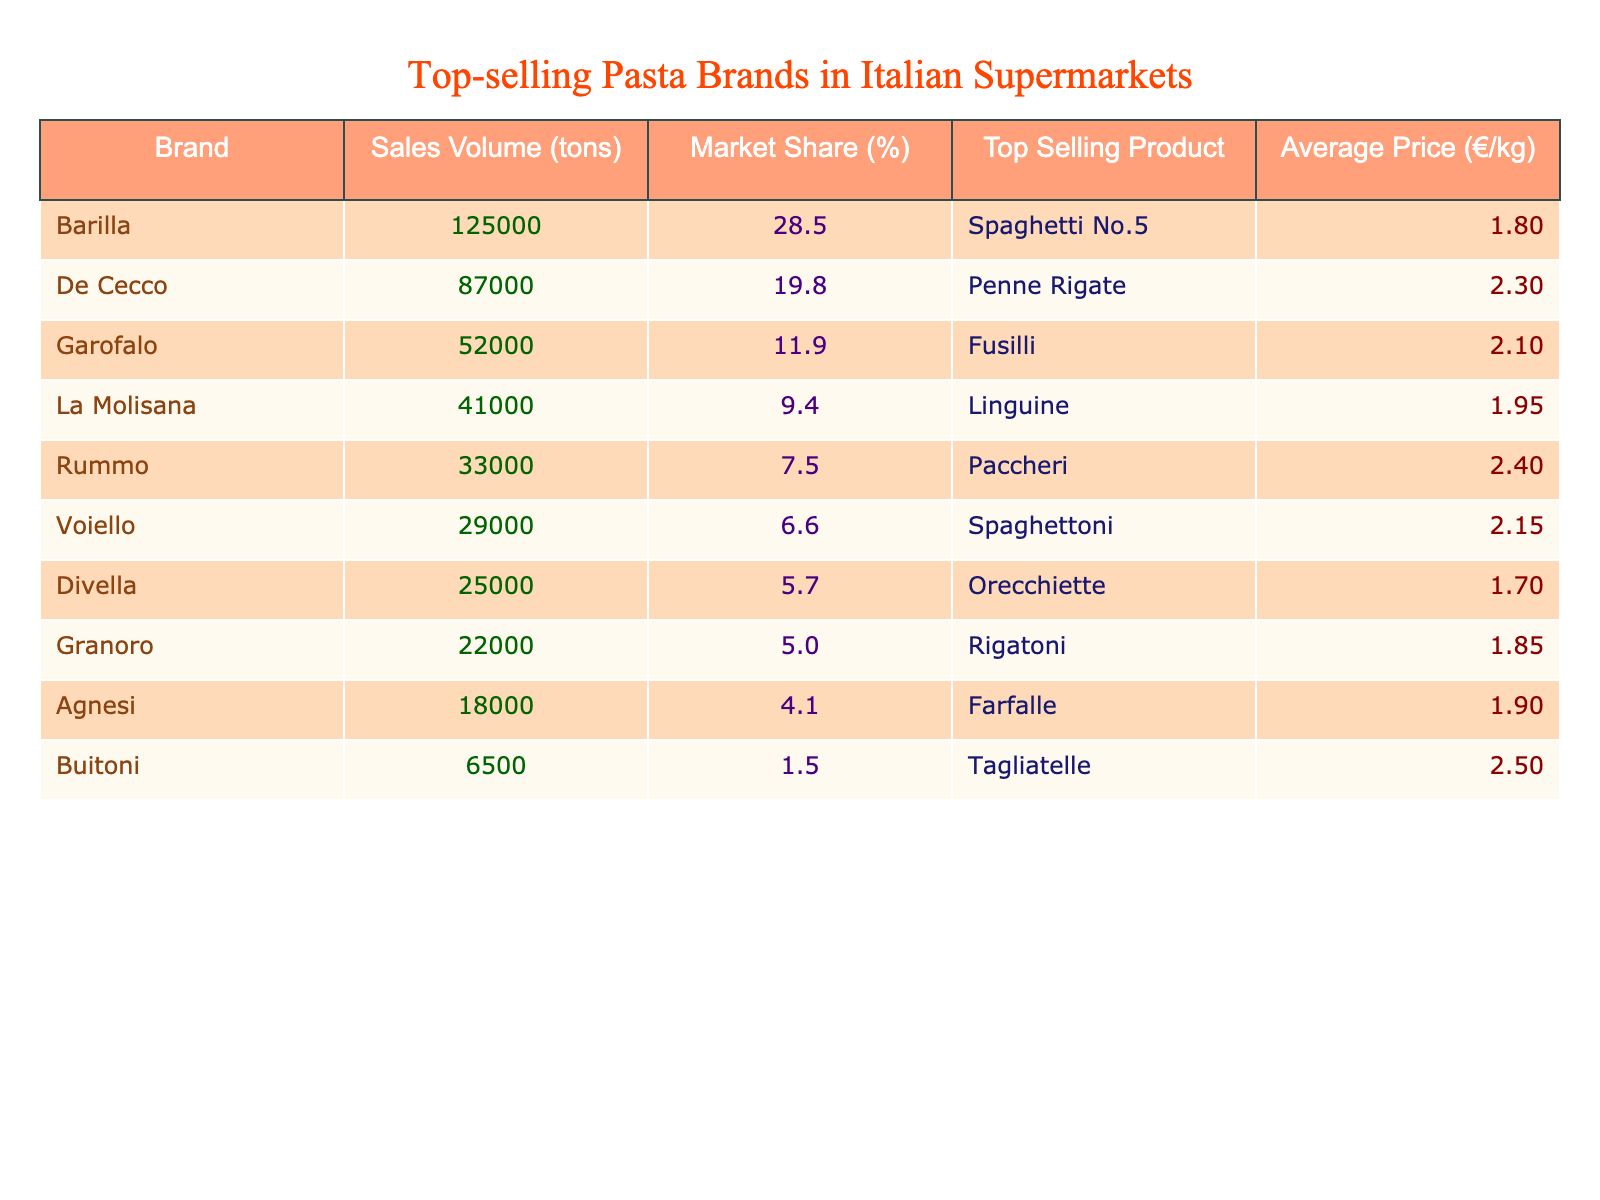What's the top-selling product of Barilla? According to the table, Barilla's top-selling product is Spaghetti No.5 as mentioned in the row corresponding to Barilla.
Answer: Spaghetti No.5 Which pasta brand has the largest market share? The largest market share is displayed next to Barilla, which has a market share of 28.5%.
Answer: Barilla What is the average price per kilogram of Garofalo pasta? The average price per kilogram for Garofalo is shown in the table as €2.10.
Answer: €2.10 How much is the sales volume of De Cecco? The sales volume is stated as 87,000 tons in the row for De Cecco.
Answer: 87,000 tons Which brand's average price is the highest? Looking through the table, Buitoni has the highest average price of €2.50.
Answer: Buitoni What is the total sales volume of the top three pasta brands? To get the total sales volume of Barilla, De Cecco, and Garofalo, we calculate 125,000 + 87,000 + 52,000 = 264,000 tons.
Answer: 264,000 tons Is Divella's market share greater than 5%? The table indicates that Divella has a market share of 5.7%, which is greater than 5%.
Answer: Yes What is the difference in sales volume between La Molisana and Rummo? The sales volume for La Molisana is 41,000 tons and for Rummo is 33,000 tons. The difference is 41,000 - 33,000 = 8,000 tons.
Answer: 8,000 tons Which brand sells Spaghettoni, and how does its market share compare to Granoro? Voiello sells Spaghettoni, with a market share of 6.6%. Granoro has a market share of 5.0%, which is lower than Voiello’s.
Answer: Voiello; higher If we consider the average price of the bottom three brands, what is their mean price? The average price for Buitoni (€2.50), Agnesi (€1.90), and Granoro (€1.85) is calculated as (2.50 + 1.90 + 1.85)/3 = 2.08.
Answer: €2.08 